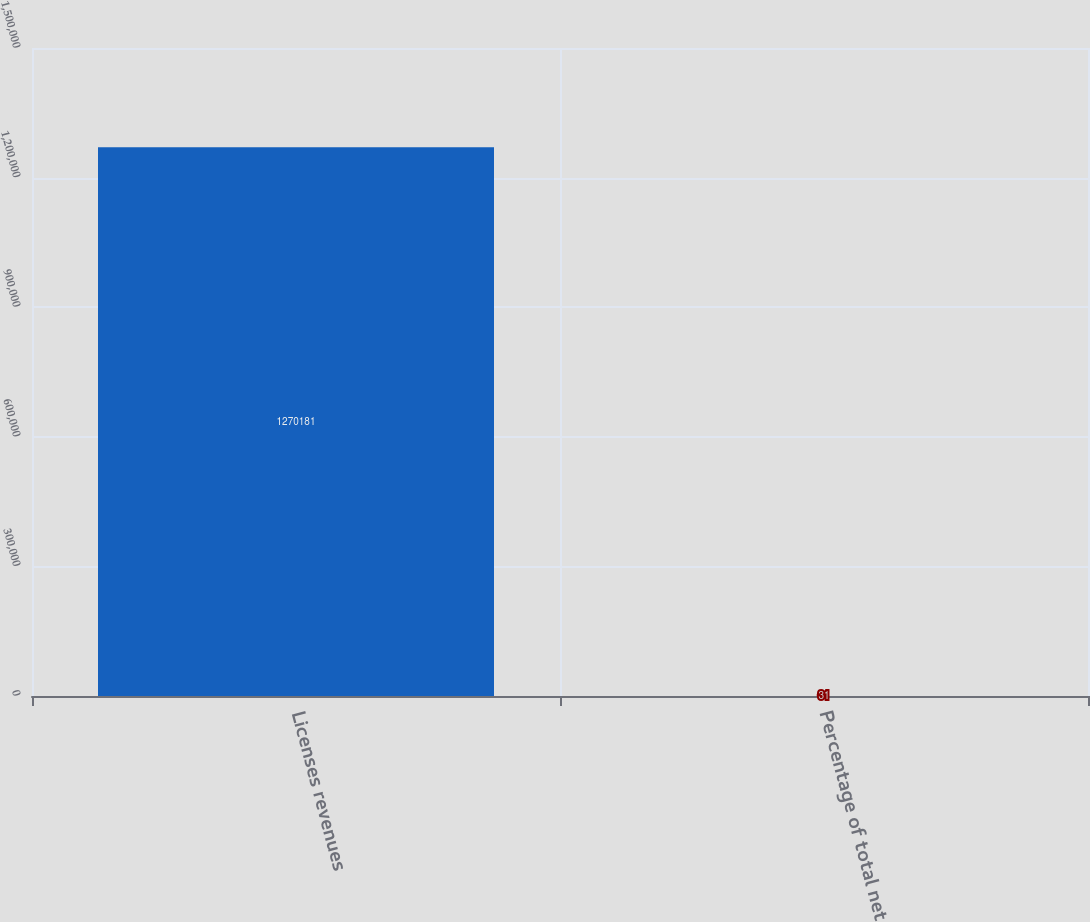Convert chart. <chart><loc_0><loc_0><loc_500><loc_500><bar_chart><fcel>Licenses revenues<fcel>Percentage of total net<nl><fcel>1.27018e+06<fcel>31<nl></chart> 